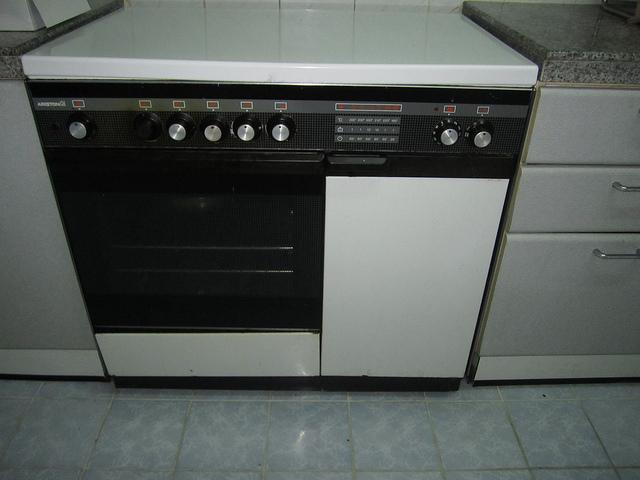Does this appliance have a range top?
Answer briefly. No. Does this appliance have dials or levers?
Short answer required. Dials. How many burners are there in the stove?
Concise answer only. 0. Is the floor carpeted?
Short answer required. No. 